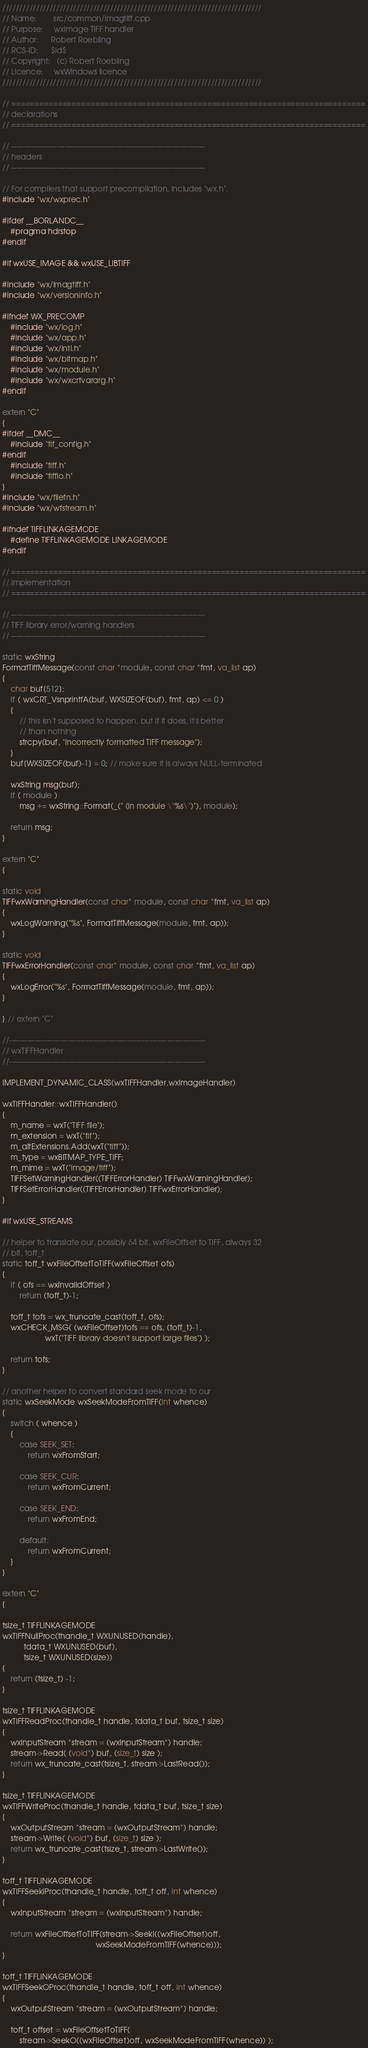<code> <loc_0><loc_0><loc_500><loc_500><_C++_>/////////////////////////////////////////////////////////////////////////////
// Name:        src/common/imagtiff.cpp
// Purpose:     wxImage TIFF handler
// Author:      Robert Roebling
// RCS-ID:      $Id$
// Copyright:   (c) Robert Roebling
// Licence:     wxWindows licence
/////////////////////////////////////////////////////////////////////////////

// ============================================================================
// declarations
// ============================================================================

// ----------------------------------------------------------------------------
// headers
// ----------------------------------------------------------------------------

// For compilers that support precompilation, includes "wx.h".
#include "wx/wxprec.h"

#ifdef __BORLANDC__
    #pragma hdrstop
#endif

#if wxUSE_IMAGE && wxUSE_LIBTIFF

#include "wx/imagtiff.h"
#include "wx/versioninfo.h"

#ifndef WX_PRECOMP
    #include "wx/log.h"
    #include "wx/app.h"
    #include "wx/intl.h"
    #include "wx/bitmap.h"
    #include "wx/module.h"
    #include "wx/wxcrtvararg.h"
#endif

extern "C"
{
#ifdef __DMC__
    #include "tif_config.h"
#endif
    #include "tiff.h"
    #include "tiffio.h"
}
#include "wx/filefn.h"
#include "wx/wfstream.h"

#ifndef TIFFLINKAGEMODE
    #define TIFFLINKAGEMODE LINKAGEMODE
#endif

// ============================================================================
// implementation
// ============================================================================

// ----------------------------------------------------------------------------
// TIFF library error/warning handlers
// ----------------------------------------------------------------------------

static wxString
FormatTiffMessage(const char *module, const char *fmt, va_list ap)
{
    char buf[512];
    if ( wxCRT_VsnprintfA(buf, WXSIZEOF(buf), fmt, ap) <= 0 )
    {
        // this isn't supposed to happen, but if it does, it's better
        // than nothing
        strcpy(buf, "Incorrectly formatted TIFF message");
    }
    buf[WXSIZEOF(buf)-1] = 0; // make sure it is always NULL-terminated

    wxString msg(buf);
    if ( module )
        msg += wxString::Format(_(" (in module \"%s\")"), module);

    return msg;
}

extern "C"
{

static void
TIFFwxWarningHandler(const char* module, const char *fmt, va_list ap)
{
    wxLogWarning("%s", FormatTiffMessage(module, fmt, ap));
}

static void
TIFFwxErrorHandler(const char* module, const char *fmt, va_list ap)
{
    wxLogError("%s", FormatTiffMessage(module, fmt, ap));
}

} // extern "C"

//-----------------------------------------------------------------------------
// wxTIFFHandler
//-----------------------------------------------------------------------------

IMPLEMENT_DYNAMIC_CLASS(wxTIFFHandler,wxImageHandler)

wxTIFFHandler::wxTIFFHandler()
{
    m_name = wxT("TIFF file");
    m_extension = wxT("tif");
    m_altExtensions.Add(wxT("tiff"));
    m_type = wxBITMAP_TYPE_TIFF;
    m_mime = wxT("image/tiff");
    TIFFSetWarningHandler((TIFFErrorHandler) TIFFwxWarningHandler);
    TIFFSetErrorHandler((TIFFErrorHandler) TIFFwxErrorHandler);
}

#if wxUSE_STREAMS

// helper to translate our, possibly 64 bit, wxFileOffset to TIFF, always 32
// bit, toff_t
static toff_t wxFileOffsetToTIFF(wxFileOffset ofs)
{
    if ( ofs == wxInvalidOffset )
        return (toff_t)-1;

    toff_t tofs = wx_truncate_cast(toff_t, ofs);
    wxCHECK_MSG( (wxFileOffset)tofs == ofs, (toff_t)-1,
                    wxT("TIFF library doesn't support large files") );

    return tofs;
}

// another helper to convert standard seek mode to our
static wxSeekMode wxSeekModeFromTIFF(int whence)
{
    switch ( whence )
    {
        case SEEK_SET:
            return wxFromStart;

        case SEEK_CUR:
            return wxFromCurrent;

        case SEEK_END:
            return wxFromEnd;

        default:
            return wxFromCurrent;
    }
}

extern "C"
{

tsize_t TIFFLINKAGEMODE
wxTIFFNullProc(thandle_t WXUNUSED(handle),
          tdata_t WXUNUSED(buf),
          tsize_t WXUNUSED(size))
{
    return (tsize_t) -1;
}

tsize_t TIFFLINKAGEMODE
wxTIFFReadProc(thandle_t handle, tdata_t buf, tsize_t size)
{
    wxInputStream *stream = (wxInputStream*) handle;
    stream->Read( (void*) buf, (size_t) size );
    return wx_truncate_cast(tsize_t, stream->LastRead());
}

tsize_t TIFFLINKAGEMODE
wxTIFFWriteProc(thandle_t handle, tdata_t buf, tsize_t size)
{
    wxOutputStream *stream = (wxOutputStream*) handle;
    stream->Write( (void*) buf, (size_t) size );
    return wx_truncate_cast(tsize_t, stream->LastWrite());
}

toff_t TIFFLINKAGEMODE
wxTIFFSeekIProc(thandle_t handle, toff_t off, int whence)
{
    wxInputStream *stream = (wxInputStream*) handle;

    return wxFileOffsetToTIFF(stream->SeekI((wxFileOffset)off,
                                            wxSeekModeFromTIFF(whence)));
}

toff_t TIFFLINKAGEMODE
wxTIFFSeekOProc(thandle_t handle, toff_t off, int whence)
{
    wxOutputStream *stream = (wxOutputStream*) handle;

    toff_t offset = wxFileOffsetToTIFF(
        stream->SeekO((wxFileOffset)off, wxSeekModeFromTIFF(whence)) );
</code> 